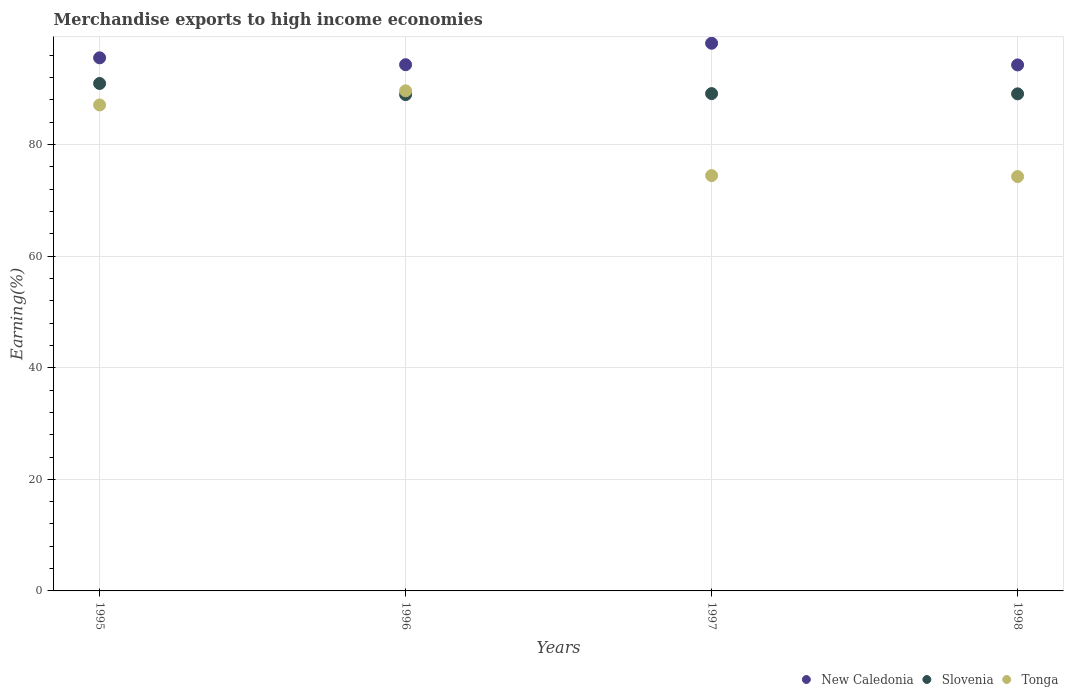How many different coloured dotlines are there?
Offer a very short reply. 3. What is the percentage of amount earned from merchandise exports in New Caledonia in 1996?
Offer a terse response. 94.32. Across all years, what is the maximum percentage of amount earned from merchandise exports in Tonga?
Provide a short and direct response. 89.64. Across all years, what is the minimum percentage of amount earned from merchandise exports in Slovenia?
Offer a very short reply. 88.96. What is the total percentage of amount earned from merchandise exports in Slovenia in the graph?
Your answer should be compact. 358.17. What is the difference between the percentage of amount earned from merchandise exports in Slovenia in 1996 and that in 1997?
Provide a short and direct response. -0.18. What is the difference between the percentage of amount earned from merchandise exports in Tonga in 1995 and the percentage of amount earned from merchandise exports in New Caledonia in 1997?
Offer a very short reply. -11.06. What is the average percentage of amount earned from merchandise exports in Tonga per year?
Provide a succinct answer. 81.37. In the year 1996, what is the difference between the percentage of amount earned from merchandise exports in New Caledonia and percentage of amount earned from merchandise exports in Slovenia?
Ensure brevity in your answer.  5.36. In how many years, is the percentage of amount earned from merchandise exports in Slovenia greater than 8 %?
Ensure brevity in your answer.  4. What is the ratio of the percentage of amount earned from merchandise exports in Slovenia in 1996 to that in 1998?
Your answer should be very brief. 1. Is the percentage of amount earned from merchandise exports in New Caledonia in 1996 less than that in 1998?
Your answer should be very brief. No. What is the difference between the highest and the second highest percentage of amount earned from merchandise exports in Slovenia?
Provide a succinct answer. 1.81. What is the difference between the highest and the lowest percentage of amount earned from merchandise exports in New Caledonia?
Provide a short and direct response. 3.89. Is the sum of the percentage of amount earned from merchandise exports in Tonga in 1995 and 1997 greater than the maximum percentage of amount earned from merchandise exports in New Caledonia across all years?
Provide a short and direct response. Yes. Is it the case that in every year, the sum of the percentage of amount earned from merchandise exports in Tonga and percentage of amount earned from merchandise exports in Slovenia  is greater than the percentage of amount earned from merchandise exports in New Caledonia?
Offer a very short reply. Yes. Does the percentage of amount earned from merchandise exports in New Caledonia monotonically increase over the years?
Make the answer very short. No. Is the percentage of amount earned from merchandise exports in Tonga strictly less than the percentage of amount earned from merchandise exports in New Caledonia over the years?
Your answer should be very brief. Yes. How many years are there in the graph?
Your response must be concise. 4. Are the values on the major ticks of Y-axis written in scientific E-notation?
Your response must be concise. No. Does the graph contain any zero values?
Keep it short and to the point. No. Where does the legend appear in the graph?
Your answer should be compact. Bottom right. How are the legend labels stacked?
Your response must be concise. Horizontal. What is the title of the graph?
Your response must be concise. Merchandise exports to high income economies. Does "Lebanon" appear as one of the legend labels in the graph?
Offer a terse response. No. What is the label or title of the X-axis?
Provide a short and direct response. Years. What is the label or title of the Y-axis?
Your answer should be compact. Earning(%). What is the Earning(%) in New Caledonia in 1995?
Your response must be concise. 95.56. What is the Earning(%) in Slovenia in 1995?
Keep it short and to the point. 90.96. What is the Earning(%) of Tonga in 1995?
Offer a very short reply. 87.11. What is the Earning(%) in New Caledonia in 1996?
Give a very brief answer. 94.32. What is the Earning(%) of Slovenia in 1996?
Provide a short and direct response. 88.96. What is the Earning(%) of Tonga in 1996?
Ensure brevity in your answer.  89.64. What is the Earning(%) in New Caledonia in 1997?
Offer a very short reply. 98.17. What is the Earning(%) of Slovenia in 1997?
Offer a terse response. 89.14. What is the Earning(%) of Tonga in 1997?
Your answer should be very brief. 74.45. What is the Earning(%) of New Caledonia in 1998?
Your answer should be very brief. 94.28. What is the Earning(%) in Slovenia in 1998?
Provide a succinct answer. 89.1. What is the Earning(%) of Tonga in 1998?
Keep it short and to the point. 74.27. Across all years, what is the maximum Earning(%) in New Caledonia?
Your response must be concise. 98.17. Across all years, what is the maximum Earning(%) in Slovenia?
Keep it short and to the point. 90.96. Across all years, what is the maximum Earning(%) in Tonga?
Provide a short and direct response. 89.64. Across all years, what is the minimum Earning(%) of New Caledonia?
Your answer should be compact. 94.28. Across all years, what is the minimum Earning(%) in Slovenia?
Provide a succinct answer. 88.96. Across all years, what is the minimum Earning(%) of Tonga?
Your response must be concise. 74.27. What is the total Earning(%) in New Caledonia in the graph?
Your answer should be very brief. 382.34. What is the total Earning(%) of Slovenia in the graph?
Make the answer very short. 358.17. What is the total Earning(%) of Tonga in the graph?
Make the answer very short. 325.47. What is the difference between the Earning(%) of New Caledonia in 1995 and that in 1996?
Your response must be concise. 1.24. What is the difference between the Earning(%) in Slovenia in 1995 and that in 1996?
Provide a short and direct response. 1.99. What is the difference between the Earning(%) of Tonga in 1995 and that in 1996?
Provide a succinct answer. -2.54. What is the difference between the Earning(%) of New Caledonia in 1995 and that in 1997?
Give a very brief answer. -2.61. What is the difference between the Earning(%) of Slovenia in 1995 and that in 1997?
Offer a terse response. 1.81. What is the difference between the Earning(%) of Tonga in 1995 and that in 1997?
Give a very brief answer. 12.66. What is the difference between the Earning(%) of New Caledonia in 1995 and that in 1998?
Provide a succinct answer. 1.27. What is the difference between the Earning(%) in Slovenia in 1995 and that in 1998?
Your answer should be very brief. 1.86. What is the difference between the Earning(%) of Tonga in 1995 and that in 1998?
Provide a short and direct response. 12.84. What is the difference between the Earning(%) in New Caledonia in 1996 and that in 1997?
Your answer should be compact. -3.85. What is the difference between the Earning(%) in Slovenia in 1996 and that in 1997?
Offer a very short reply. -0.18. What is the difference between the Earning(%) of Tonga in 1996 and that in 1997?
Provide a succinct answer. 15.2. What is the difference between the Earning(%) of New Caledonia in 1996 and that in 1998?
Offer a terse response. 0.04. What is the difference between the Earning(%) of Slovenia in 1996 and that in 1998?
Your answer should be very brief. -0.14. What is the difference between the Earning(%) in Tonga in 1996 and that in 1998?
Your answer should be compact. 15.37. What is the difference between the Earning(%) in New Caledonia in 1997 and that in 1998?
Your answer should be compact. 3.89. What is the difference between the Earning(%) of Slovenia in 1997 and that in 1998?
Give a very brief answer. 0.04. What is the difference between the Earning(%) of Tonga in 1997 and that in 1998?
Offer a very short reply. 0.17. What is the difference between the Earning(%) in New Caledonia in 1995 and the Earning(%) in Slovenia in 1996?
Provide a short and direct response. 6.59. What is the difference between the Earning(%) of New Caledonia in 1995 and the Earning(%) of Tonga in 1996?
Your answer should be very brief. 5.92. What is the difference between the Earning(%) of Slovenia in 1995 and the Earning(%) of Tonga in 1996?
Ensure brevity in your answer.  1.31. What is the difference between the Earning(%) in New Caledonia in 1995 and the Earning(%) in Slovenia in 1997?
Offer a very short reply. 6.42. What is the difference between the Earning(%) of New Caledonia in 1995 and the Earning(%) of Tonga in 1997?
Ensure brevity in your answer.  21.11. What is the difference between the Earning(%) in Slovenia in 1995 and the Earning(%) in Tonga in 1997?
Offer a very short reply. 16.51. What is the difference between the Earning(%) in New Caledonia in 1995 and the Earning(%) in Slovenia in 1998?
Your answer should be very brief. 6.46. What is the difference between the Earning(%) of New Caledonia in 1995 and the Earning(%) of Tonga in 1998?
Give a very brief answer. 21.29. What is the difference between the Earning(%) of Slovenia in 1995 and the Earning(%) of Tonga in 1998?
Your answer should be compact. 16.68. What is the difference between the Earning(%) of New Caledonia in 1996 and the Earning(%) of Slovenia in 1997?
Offer a very short reply. 5.18. What is the difference between the Earning(%) in New Caledonia in 1996 and the Earning(%) in Tonga in 1997?
Offer a very short reply. 19.88. What is the difference between the Earning(%) in Slovenia in 1996 and the Earning(%) in Tonga in 1997?
Give a very brief answer. 14.52. What is the difference between the Earning(%) in New Caledonia in 1996 and the Earning(%) in Slovenia in 1998?
Your response must be concise. 5.22. What is the difference between the Earning(%) in New Caledonia in 1996 and the Earning(%) in Tonga in 1998?
Provide a succinct answer. 20.05. What is the difference between the Earning(%) of Slovenia in 1996 and the Earning(%) of Tonga in 1998?
Offer a terse response. 14.69. What is the difference between the Earning(%) in New Caledonia in 1997 and the Earning(%) in Slovenia in 1998?
Give a very brief answer. 9.07. What is the difference between the Earning(%) in New Caledonia in 1997 and the Earning(%) in Tonga in 1998?
Make the answer very short. 23.9. What is the difference between the Earning(%) in Slovenia in 1997 and the Earning(%) in Tonga in 1998?
Make the answer very short. 14.87. What is the average Earning(%) in New Caledonia per year?
Your answer should be very brief. 95.58. What is the average Earning(%) in Slovenia per year?
Keep it short and to the point. 89.54. What is the average Earning(%) of Tonga per year?
Make the answer very short. 81.37. In the year 1995, what is the difference between the Earning(%) of New Caledonia and Earning(%) of Slovenia?
Ensure brevity in your answer.  4.6. In the year 1995, what is the difference between the Earning(%) in New Caledonia and Earning(%) in Tonga?
Offer a very short reply. 8.45. In the year 1995, what is the difference between the Earning(%) in Slovenia and Earning(%) in Tonga?
Provide a short and direct response. 3.85. In the year 1996, what is the difference between the Earning(%) in New Caledonia and Earning(%) in Slovenia?
Your response must be concise. 5.36. In the year 1996, what is the difference between the Earning(%) of New Caledonia and Earning(%) of Tonga?
Your answer should be very brief. 4.68. In the year 1996, what is the difference between the Earning(%) of Slovenia and Earning(%) of Tonga?
Your answer should be very brief. -0.68. In the year 1997, what is the difference between the Earning(%) in New Caledonia and Earning(%) in Slovenia?
Your response must be concise. 9.03. In the year 1997, what is the difference between the Earning(%) of New Caledonia and Earning(%) of Tonga?
Provide a succinct answer. 23.73. In the year 1997, what is the difference between the Earning(%) of Slovenia and Earning(%) of Tonga?
Your response must be concise. 14.7. In the year 1998, what is the difference between the Earning(%) in New Caledonia and Earning(%) in Slovenia?
Ensure brevity in your answer.  5.18. In the year 1998, what is the difference between the Earning(%) of New Caledonia and Earning(%) of Tonga?
Your answer should be compact. 20.01. In the year 1998, what is the difference between the Earning(%) in Slovenia and Earning(%) in Tonga?
Your answer should be very brief. 14.83. What is the ratio of the Earning(%) of New Caledonia in 1995 to that in 1996?
Give a very brief answer. 1.01. What is the ratio of the Earning(%) of Slovenia in 1995 to that in 1996?
Your answer should be compact. 1.02. What is the ratio of the Earning(%) of Tonga in 1995 to that in 1996?
Offer a very short reply. 0.97. What is the ratio of the Earning(%) of New Caledonia in 1995 to that in 1997?
Keep it short and to the point. 0.97. What is the ratio of the Earning(%) in Slovenia in 1995 to that in 1997?
Your response must be concise. 1.02. What is the ratio of the Earning(%) of Tonga in 1995 to that in 1997?
Ensure brevity in your answer.  1.17. What is the ratio of the Earning(%) of New Caledonia in 1995 to that in 1998?
Give a very brief answer. 1.01. What is the ratio of the Earning(%) in Slovenia in 1995 to that in 1998?
Keep it short and to the point. 1.02. What is the ratio of the Earning(%) of Tonga in 1995 to that in 1998?
Provide a short and direct response. 1.17. What is the ratio of the Earning(%) of New Caledonia in 1996 to that in 1997?
Keep it short and to the point. 0.96. What is the ratio of the Earning(%) in Tonga in 1996 to that in 1997?
Make the answer very short. 1.2. What is the ratio of the Earning(%) in Tonga in 1996 to that in 1998?
Provide a short and direct response. 1.21. What is the ratio of the Earning(%) in New Caledonia in 1997 to that in 1998?
Provide a short and direct response. 1.04. What is the ratio of the Earning(%) in Slovenia in 1997 to that in 1998?
Make the answer very short. 1. What is the difference between the highest and the second highest Earning(%) in New Caledonia?
Your answer should be very brief. 2.61. What is the difference between the highest and the second highest Earning(%) in Slovenia?
Provide a short and direct response. 1.81. What is the difference between the highest and the second highest Earning(%) in Tonga?
Offer a very short reply. 2.54. What is the difference between the highest and the lowest Earning(%) of New Caledonia?
Keep it short and to the point. 3.89. What is the difference between the highest and the lowest Earning(%) in Slovenia?
Provide a short and direct response. 1.99. What is the difference between the highest and the lowest Earning(%) of Tonga?
Offer a terse response. 15.37. 